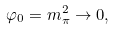<formula> <loc_0><loc_0><loc_500><loc_500>\varphi _ { 0 } = m _ { \pi } ^ { 2 } \rightarrow 0 ,</formula> 